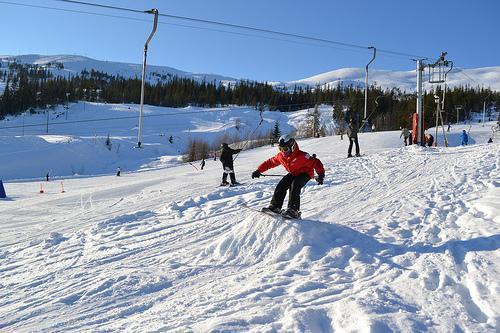How many people are in red coats?
Give a very brief answer. 1. 